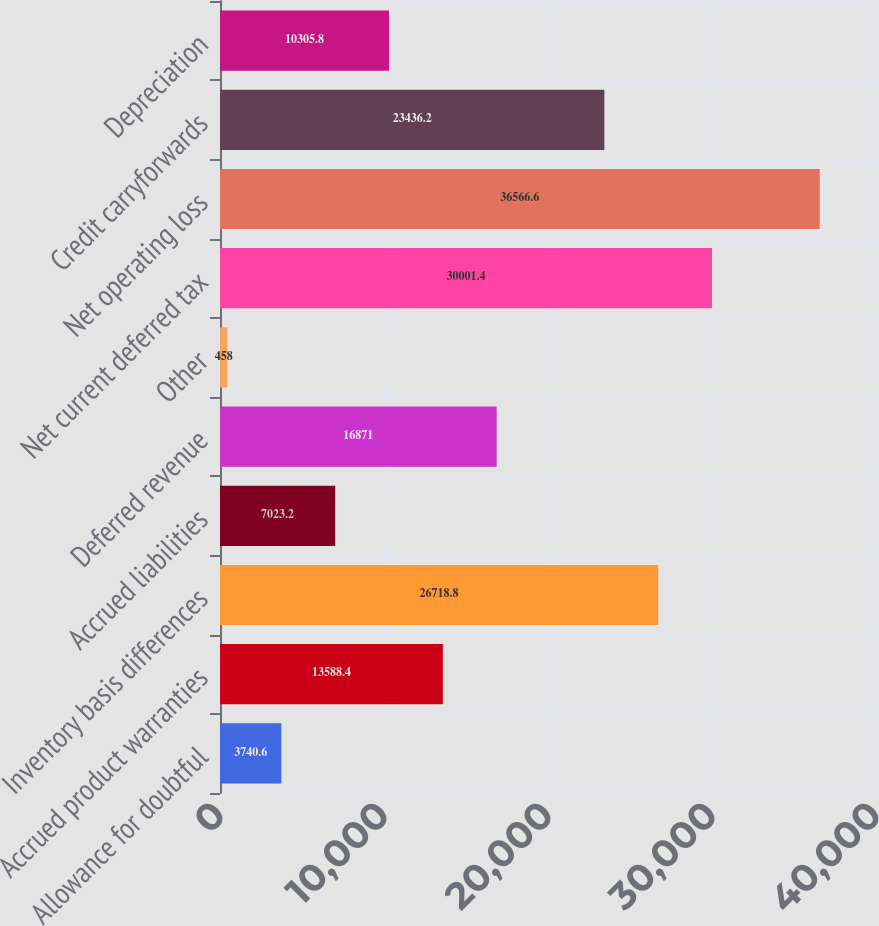Convert chart to OTSL. <chart><loc_0><loc_0><loc_500><loc_500><bar_chart><fcel>Allowance for doubtful<fcel>Accrued product warranties<fcel>Inventory basis differences<fcel>Accrued liabilities<fcel>Deferred revenue<fcel>Other<fcel>Net current deferred tax<fcel>Net operating loss<fcel>Credit carryforwards<fcel>Depreciation<nl><fcel>3740.6<fcel>13588.4<fcel>26718.8<fcel>7023.2<fcel>16871<fcel>458<fcel>30001.4<fcel>36566.6<fcel>23436.2<fcel>10305.8<nl></chart> 